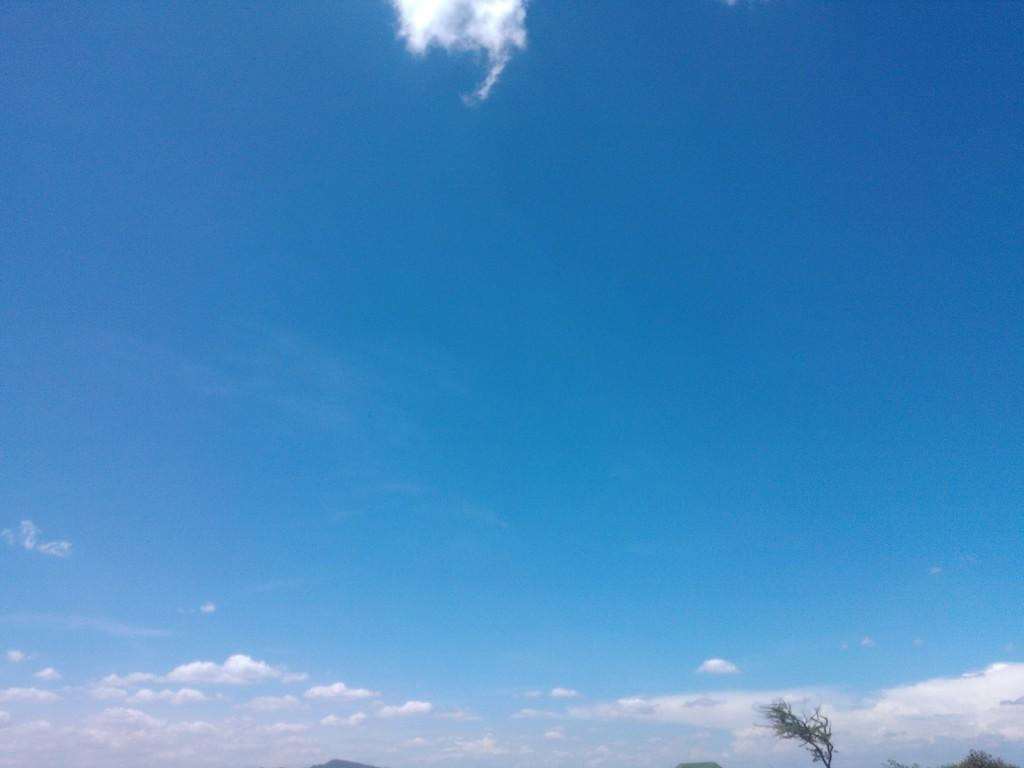What type of vegetation can be seen in the image? There are trees in the image. What is the color of the trees in the image? The trees are green in color. What can be seen in the background of the image? The sky is visible in the background of the image. What colors are present in the sky in the image? The sky is blue and white in color. Can you hear the bells ringing in the image? There are no bells present in the image, so it is not possible to hear them ringing. What type of competition is taking place in the image? There is no competition depicted in the image; it features trees and a blue and white sky. 